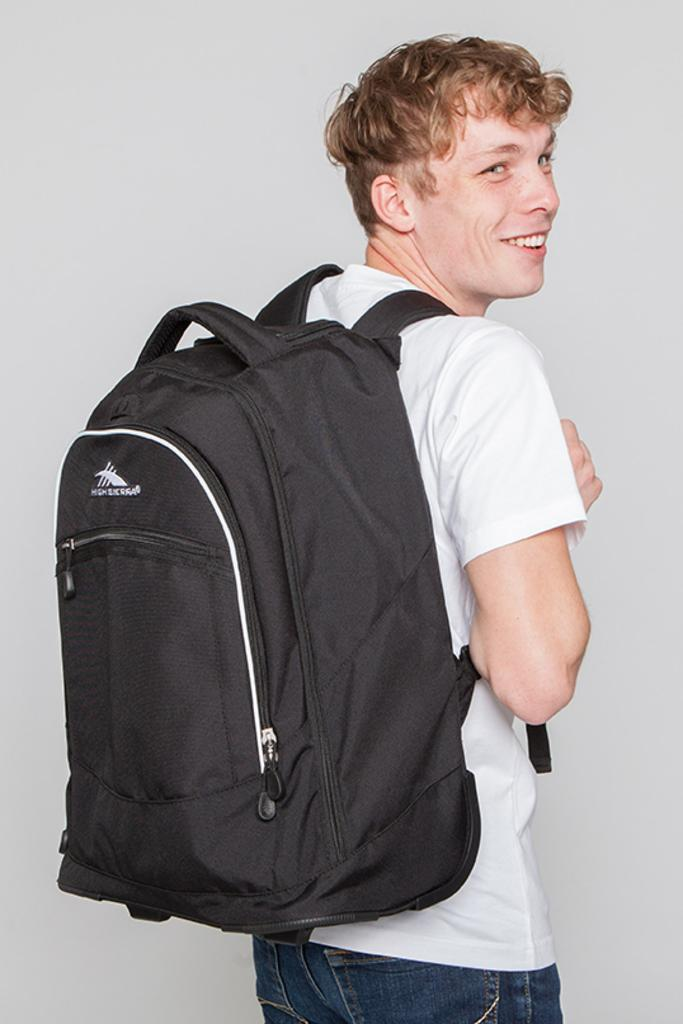Who is the main subject in the image? There is a man in the image. Where is the man positioned in the image? The man is standing in the middle of the image. What is the man's facial expression? The man is smiling. What is the man carrying on his back? The man is wearing a backpack. What type of hose is the man using to water the plants in the image? There is no hose or plants present in the image; it features a man standing and smiling while wearing a backpack. 